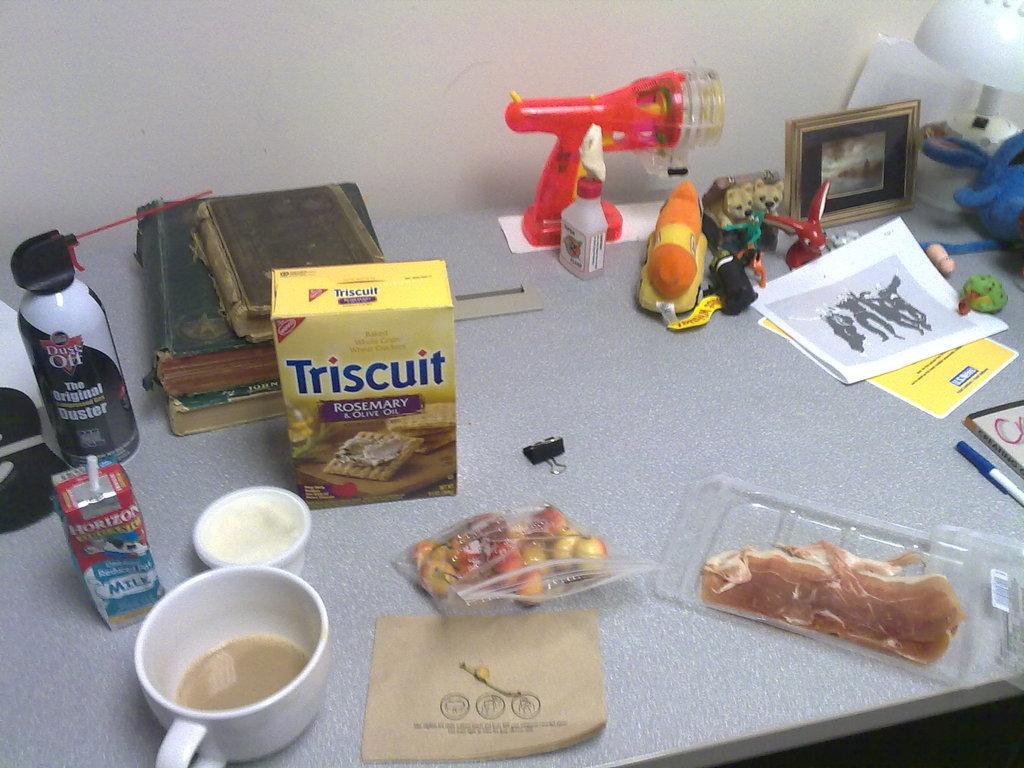Could you give a brief overview of what you see in this image? In this picture I can see the white color surface, on which I see a cup, 2 boxes, few papers, 2 books, a photo frame and other few things. 